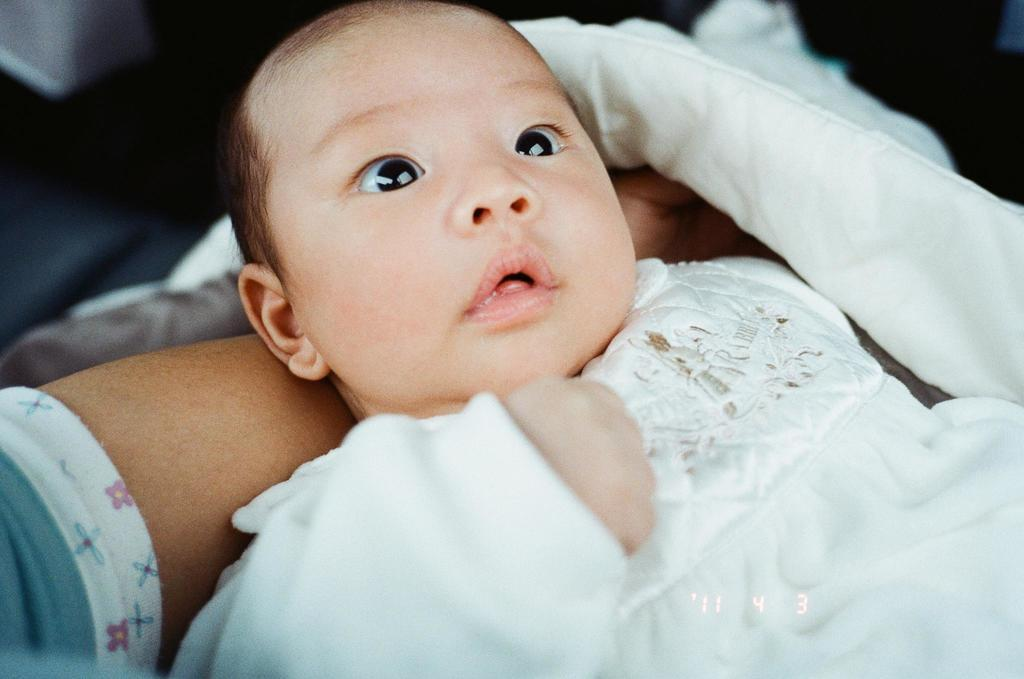What is the main subject of the image? There is a baby in the image. How is the baby being held in the image? The baby is held in a person's hand. What type of cap is the duck wearing in the image? There is no duck or cap present in the image; it features a baby being held in a person's hand. 